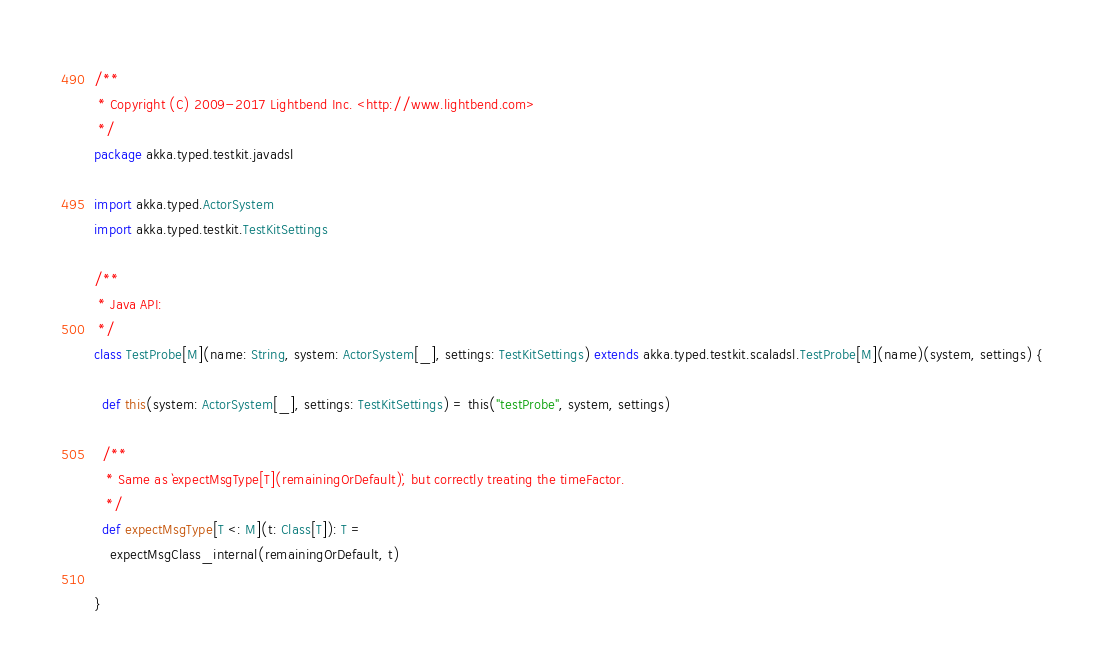Convert code to text. <code><loc_0><loc_0><loc_500><loc_500><_Scala_>/**
 * Copyright (C) 2009-2017 Lightbend Inc. <http://www.lightbend.com>
 */
package akka.typed.testkit.javadsl

import akka.typed.ActorSystem
import akka.typed.testkit.TestKitSettings

/**
 * Java API:
 */
class TestProbe[M](name: String, system: ActorSystem[_], settings: TestKitSettings) extends akka.typed.testkit.scaladsl.TestProbe[M](name)(system, settings) {

  def this(system: ActorSystem[_], settings: TestKitSettings) = this("testProbe", system, settings)

  /**
   * Same as `expectMsgType[T](remainingOrDefault)`, but correctly treating the timeFactor.
   */
  def expectMsgType[T <: M](t: Class[T]): T =
    expectMsgClass_internal(remainingOrDefault, t)

}
</code> 